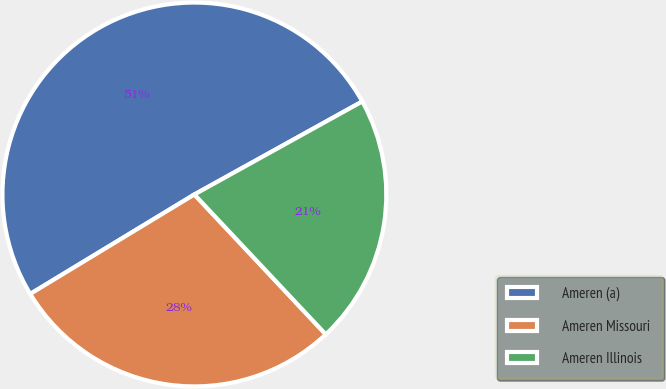Convert chart to OTSL. <chart><loc_0><loc_0><loc_500><loc_500><pie_chart><fcel>Ameren (a)<fcel>Ameren Missouri<fcel>Ameren Illinois<nl><fcel>50.62%<fcel>28.33%<fcel>21.05%<nl></chart> 